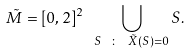Convert formula to latex. <formula><loc_0><loc_0><loc_500><loc_500>\tilde { M } = [ 0 , 2 ] ^ { 2 } \ \bigcup _ { S \ \colon \ \tilde { X } ( S ) = 0 } S .</formula> 